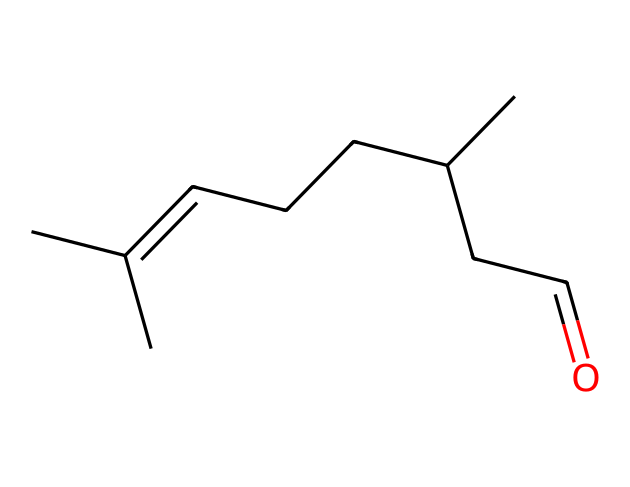What is the name of this compound? The SMILES representation indicates the molecule is structured with a carbon branch and an aldehyde functional group (C=O). From common knowledge about organic compounds, this structure corresponds to citronellal, a known mosquito repellent compound.
Answer: citronellal How many carbon atoms are in the structure? By analyzing the SMILES notation, we identify each 'C' character representing a carbon atom. Counting gives us 10 carbon atoms in total.
Answer: 10 What type of functional group is present? The presence of the C=O group indicates that this compound has an aldehyde functional group, as it appears at the end of a carbon chain.
Answer: aldehyde Is this compound saturated or unsaturated? The presence of a double bond (C=C) in the carbon chain indicates that this compound has unsaturation, meaning it contains at least one double bond.
Answer: unsaturated Which part of the structure contributes to its repellent property? The aldehyde functional group is often linked to the biological activity of compounds, including their ability to act as repellents. The specific branching of the carbon chain might also play a role in its effectiveness.
Answer: aldehyde How many double bonds are present in this molecule? Observing the structure, there is one double bond between the carbon atoms in the chain, denoted by the 'C=C' notation.
Answer: 1 